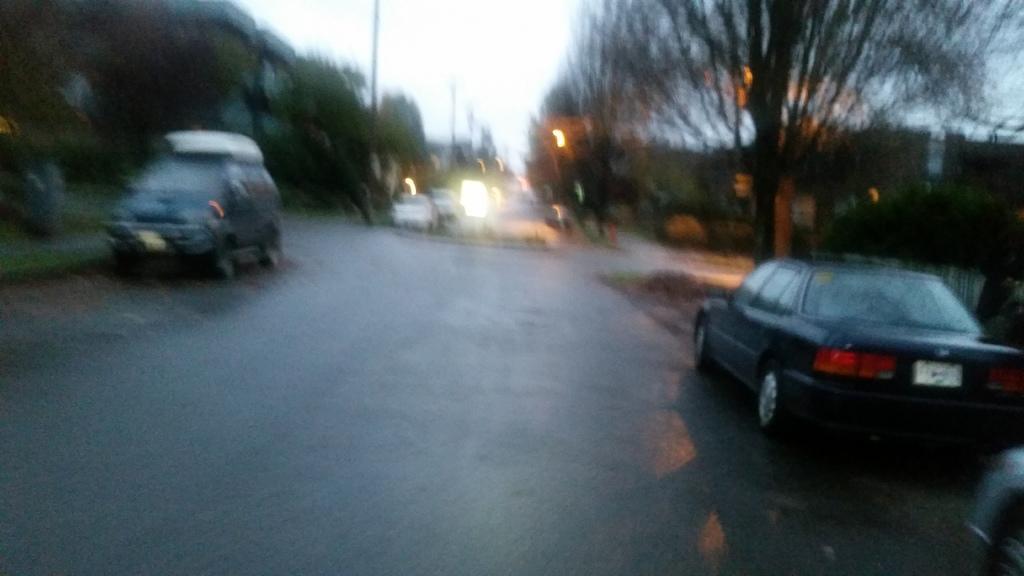Describe this image in one or two sentences. In this image we can see some vehicles on the road. We can also see a group of trees, poles and the sky. 